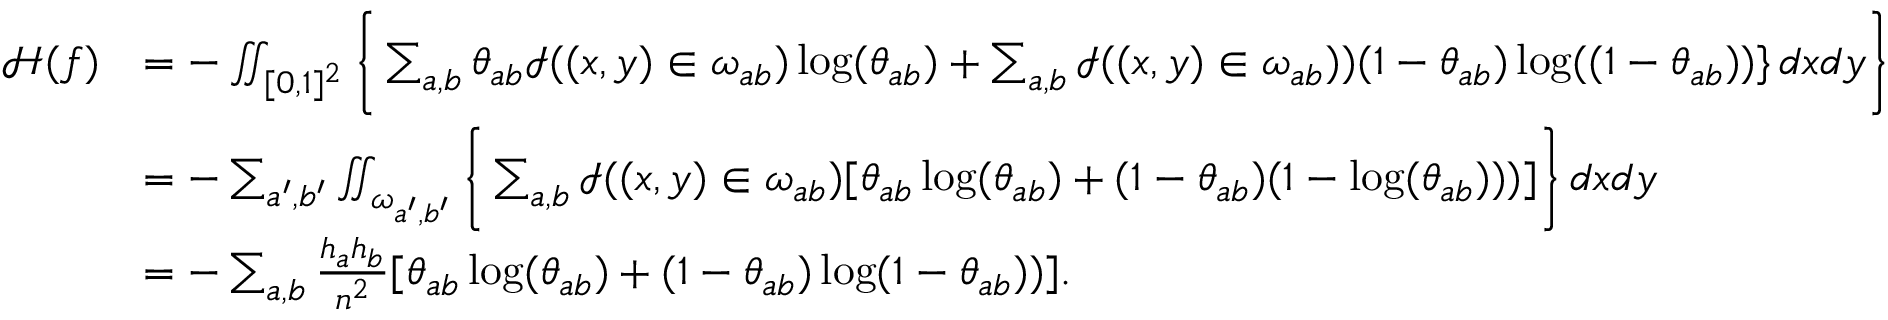<formula> <loc_0><loc_0><loc_500><loc_500>\begin{array} { r l } { { \mathcal { H } } ( f ) } & { = - \iint _ { [ 0 , 1 ] ^ { 2 } } \left \{ \sum _ { a , b } \theta _ { a b } \mathcal { I } ( ( x , y ) \in \omega _ { a b } ) \log ( \theta _ { a b } ) + \sum _ { a , b } \mathcal { I } ( ( x , y ) \in \omega _ { a b } ) ) ( 1 - \theta _ { a b } ) \log ( ( 1 - \theta _ { a b } ) ) \} \, d x d y \right \} } \\ & { = - \sum _ { a ^ { \prime } , b ^ { \prime } } \iint _ { \omega _ { a ^ { \prime } , b ^ { \prime } } } \left \{ \sum _ { a , b } \mathcal { I } ( ( x , y ) \in \omega _ { a b } ) [ \theta _ { a b } \log ( \theta _ { a b } ) + ( 1 - \theta _ { a b } ) ( 1 - \log ( \theta _ { a b } ) ) ) ] \right \} \, d x d y } \\ & { = - \sum _ { a , b } \frac { h _ { a } h _ { b } } { n ^ { 2 } } [ \theta _ { a b } \log ( \theta _ { a b } ) + ( 1 - \theta _ { a b } ) \log ( 1 - \theta _ { a b } ) ) ] . } \end{array}</formula> 